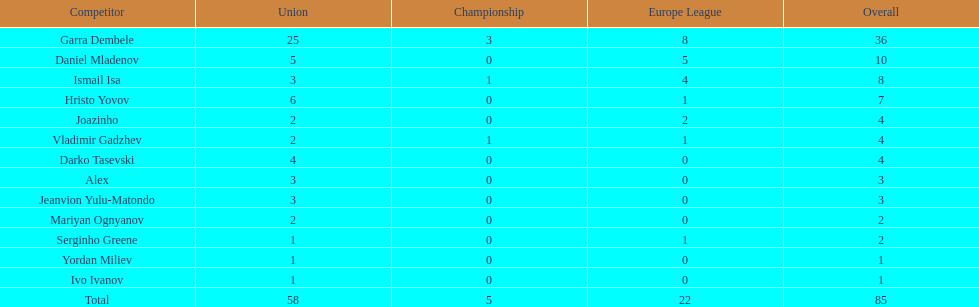Which total is higher, the europa league total or the league total? League. Could you parse the entire table? {'header': ['Competitor', 'Union', 'Championship', 'Europe League', 'Overall'], 'rows': [['Garra Dembele', '25', '3', '8', '36'], ['Daniel Mladenov', '5', '0', '5', '10'], ['Ismail Isa', '3', '1', '4', '8'], ['Hristo Yovov', '6', '0', '1', '7'], ['Joazinho', '2', '0', '2', '4'], ['Vladimir Gadzhev', '2', '1', '1', '4'], ['Darko Tasevski', '4', '0', '0', '4'], ['Alex', '3', '0', '0', '3'], ['Jeanvion Yulu-Matondo', '3', '0', '0', '3'], ['Mariyan Ognyanov', '2', '0', '0', '2'], ['Serginho Greene', '1', '0', '1', '2'], ['Yordan Miliev', '1', '0', '0', '1'], ['Ivo Ivanov', '1', '0', '0', '1'], ['Total', '58', '5', '22', '85']]} 